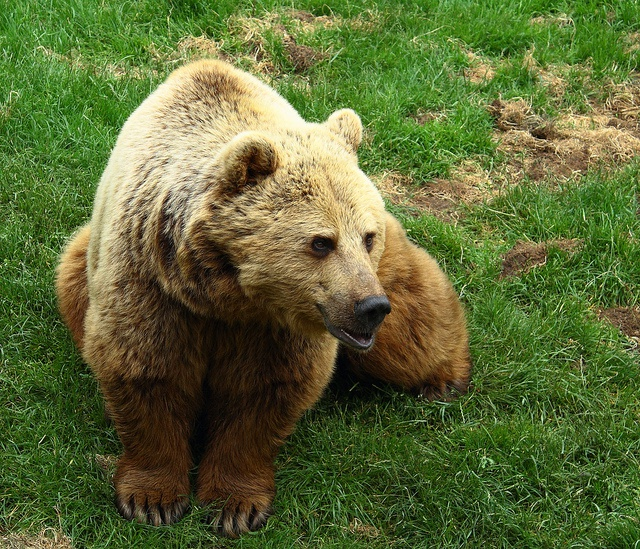Describe the objects in this image and their specific colors. I can see a bear in darkgreen, black, khaki, olive, and maroon tones in this image. 